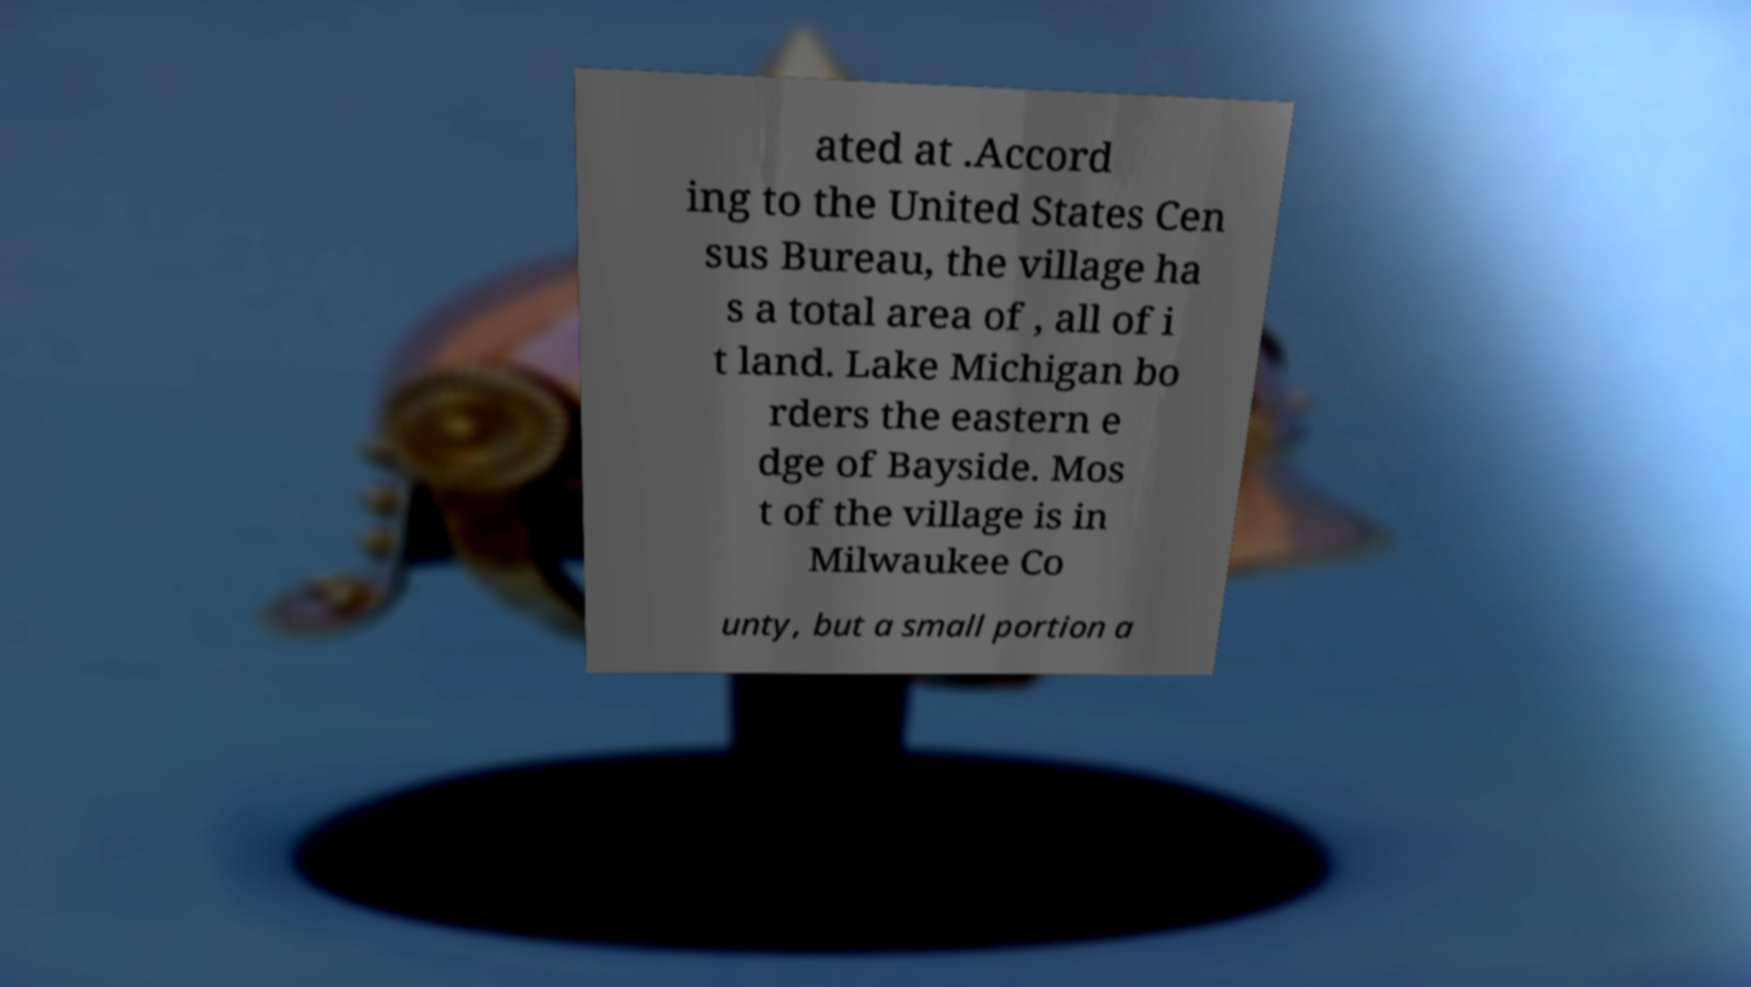Please read and relay the text visible in this image. What does it say? ated at .Accord ing to the United States Cen sus Bureau, the village ha s a total area of , all of i t land. Lake Michigan bo rders the eastern e dge of Bayside. Mos t of the village is in Milwaukee Co unty, but a small portion a 